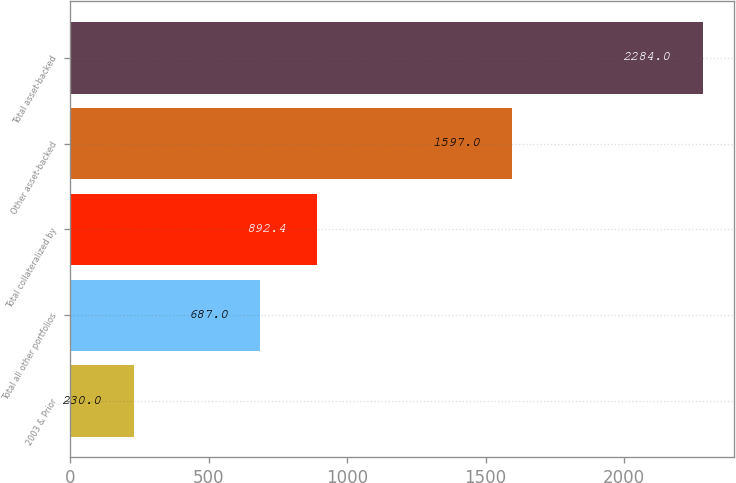Convert chart. <chart><loc_0><loc_0><loc_500><loc_500><bar_chart><fcel>2003 & Prior<fcel>Total all other portfolios<fcel>Total collateralized by<fcel>Other asset-backed<fcel>Total asset-backed<nl><fcel>230<fcel>687<fcel>892.4<fcel>1597<fcel>2284<nl></chart> 